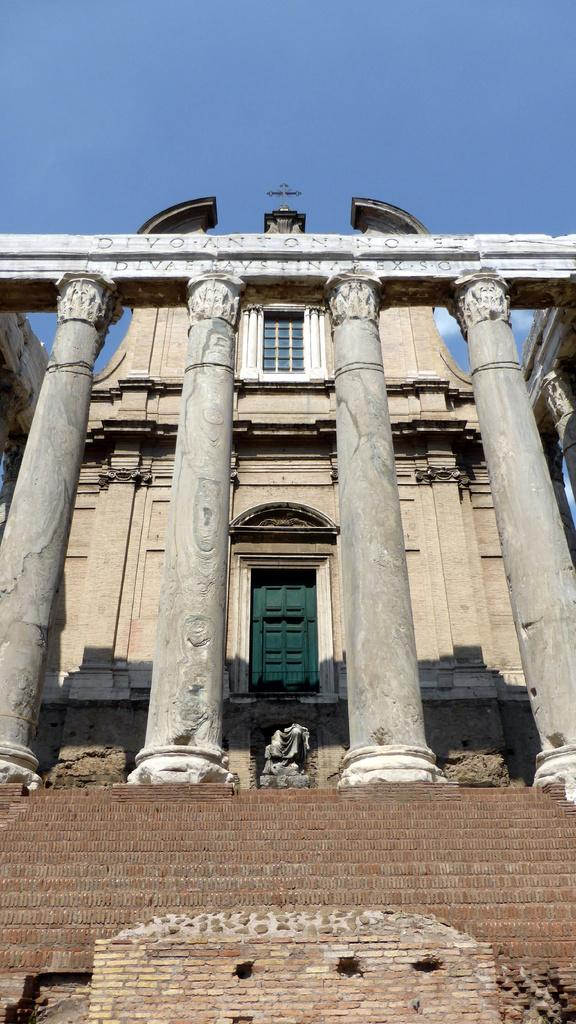What historical site is depicted in the image? The image contains the temple of Antoninus and Faustina. What direction is the temple facing in the image? The provided facts do not mention the direction the temple is facing, so it cannot be determined from the image. Who is the judge presiding over the temple in the image? There is no judge or any indication of a legal proceeding in the image; it simply depicts the temple of Antoninus and Faustina. What type of blade is being used to carve the temple in the image? There is no indication of any carving or tool usage in the image; it simply depicts the temple of Antoninus and Faustina. 